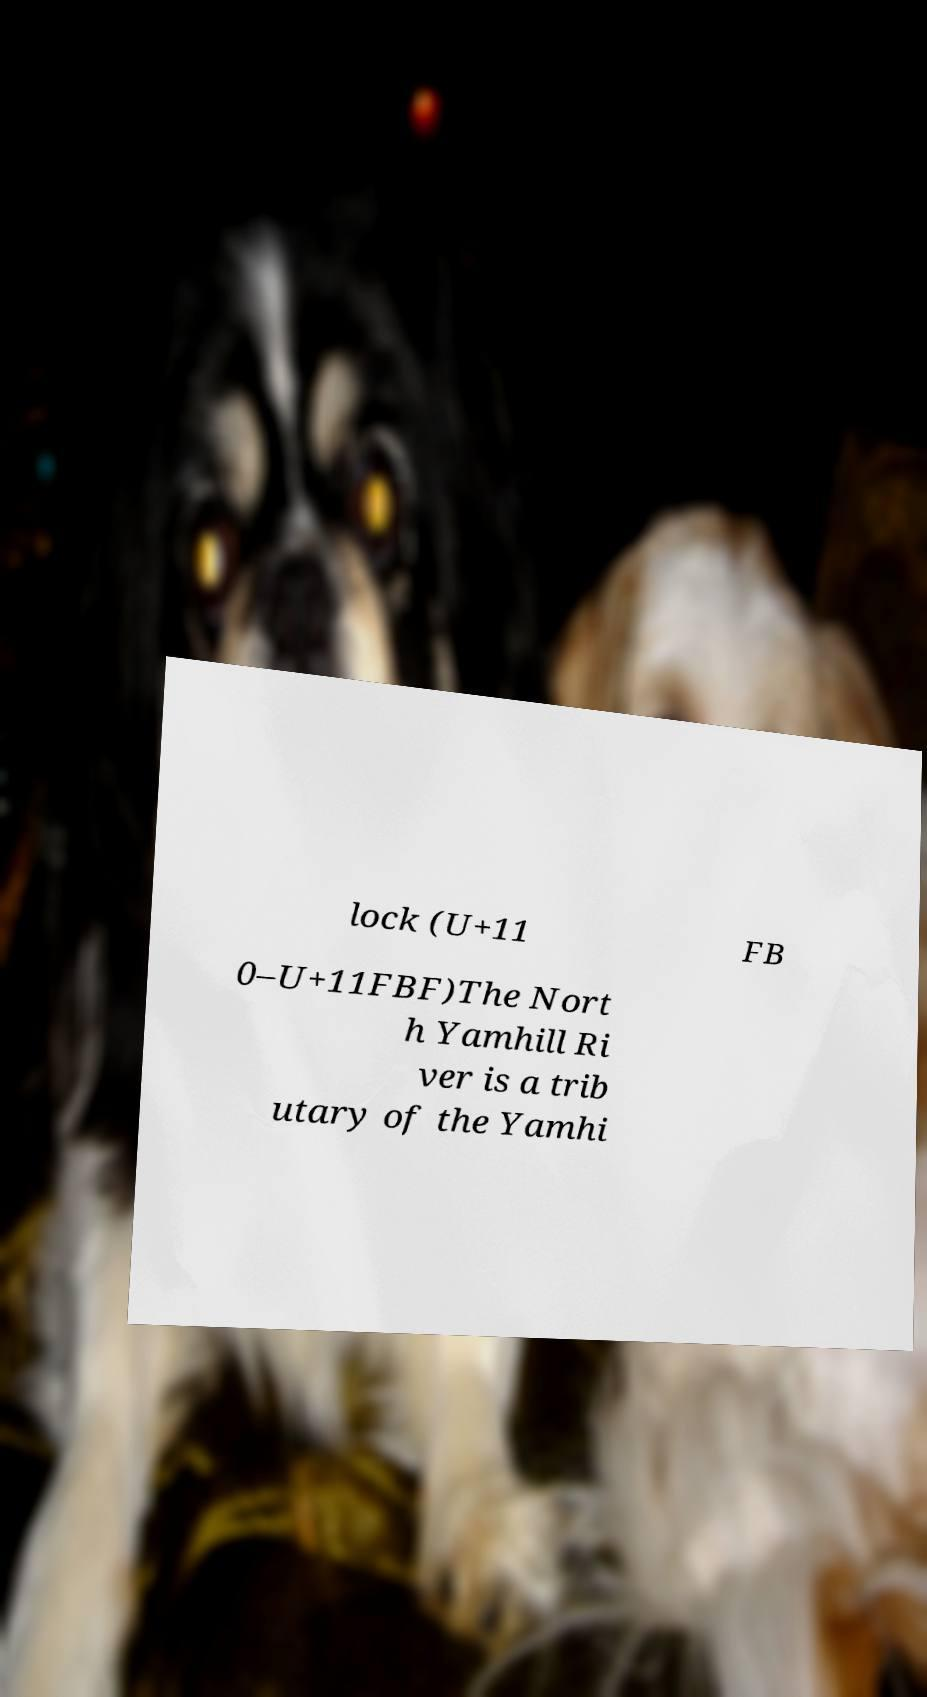Can you accurately transcribe the text from the provided image for me? lock (U+11 FB 0–U+11FBF)The Nort h Yamhill Ri ver is a trib utary of the Yamhi 